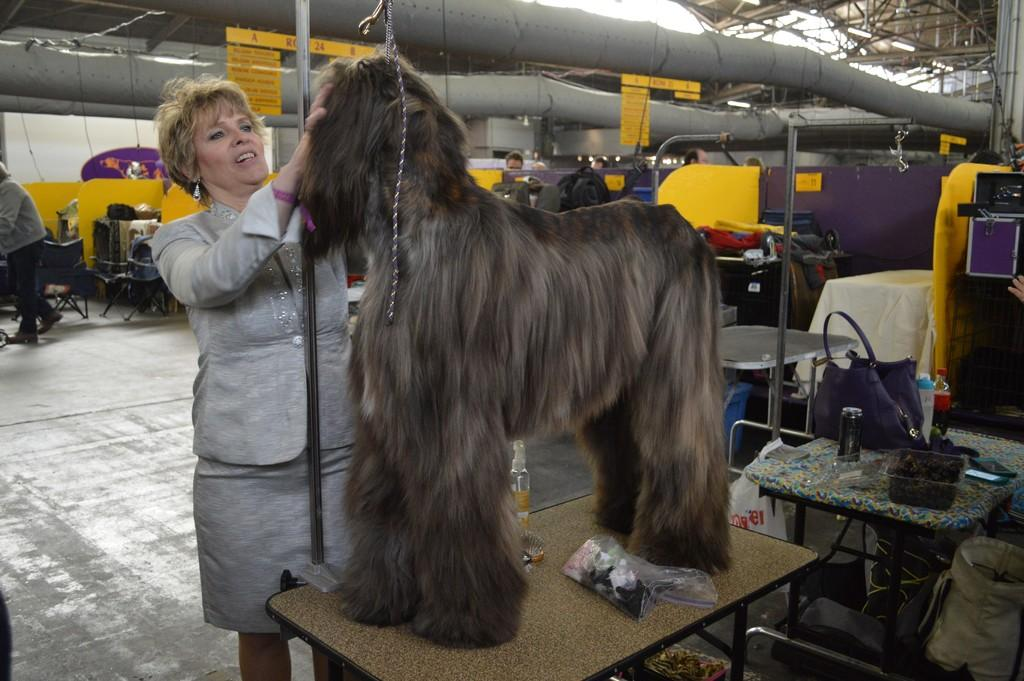Who is the main subject in the image? There is a woman in the image. What is the woman doing in the image? The woman is attempting to catch a dog. Where is the dog located in the image? The dog is on a table. What can be seen in the background of the image? There are yellow cabins in the background of the image. What type of thrill can be seen on the tramp in the image? There is no tramp present in the image, and therefore no thrill can be observed. 